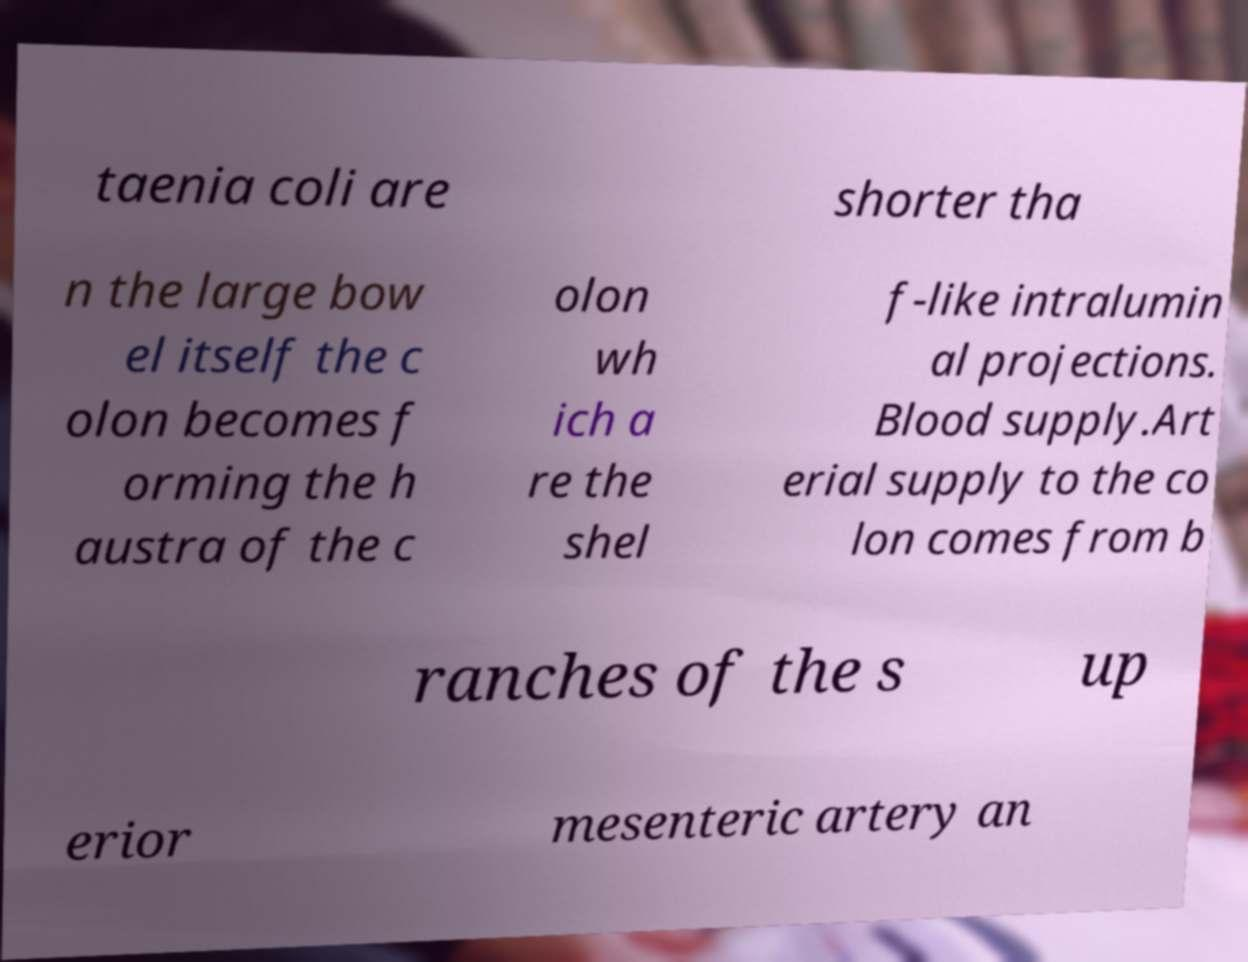Can you read and provide the text displayed in the image?This photo seems to have some interesting text. Can you extract and type it out for me? taenia coli are shorter tha n the large bow el itself the c olon becomes f orming the h austra of the c olon wh ich a re the shel f-like intralumin al projections. Blood supply.Art erial supply to the co lon comes from b ranches of the s up erior mesenteric artery an 